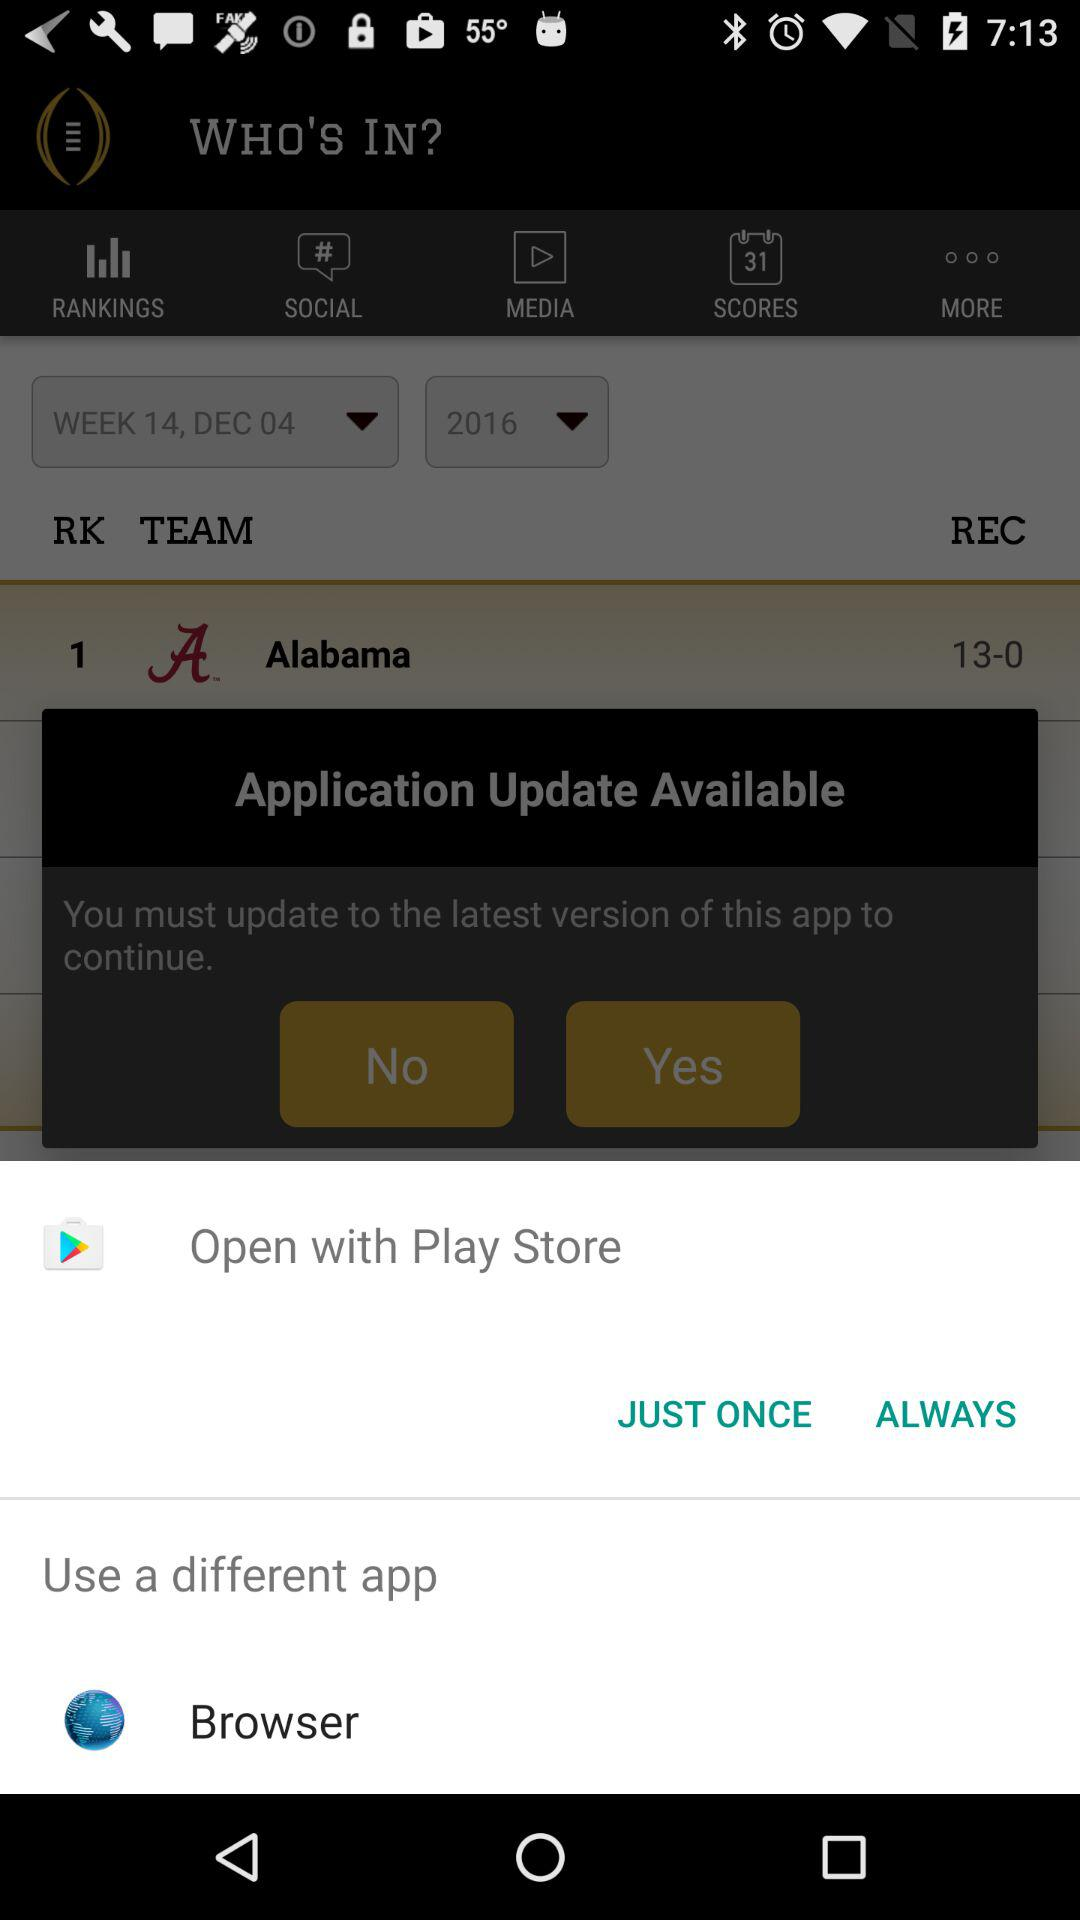Through which application can be open? The applications that can be used to open are "Play Store" and "Browser". 